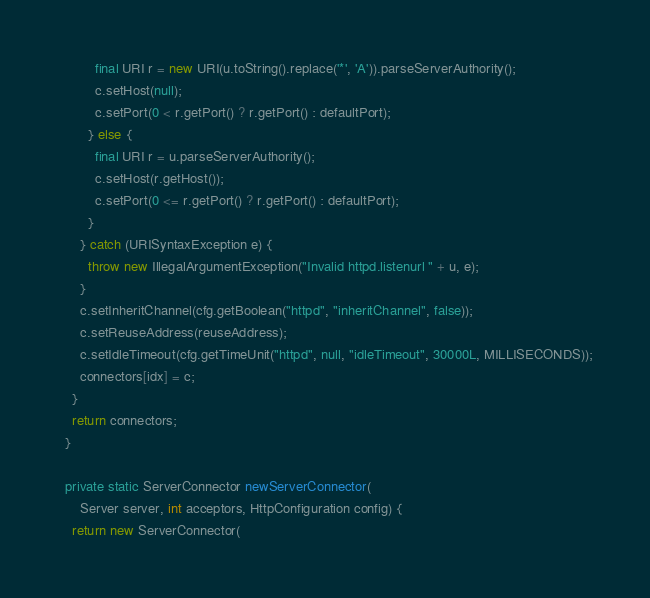Convert code to text. <code><loc_0><loc_0><loc_500><loc_500><_Java_>          final URI r = new URI(u.toString().replace('*', 'A')).parseServerAuthority();
          c.setHost(null);
          c.setPort(0 < r.getPort() ? r.getPort() : defaultPort);
        } else {
          final URI r = u.parseServerAuthority();
          c.setHost(r.getHost());
          c.setPort(0 <= r.getPort() ? r.getPort() : defaultPort);
        }
      } catch (URISyntaxException e) {
        throw new IllegalArgumentException("Invalid httpd.listenurl " + u, e);
      }
      c.setInheritChannel(cfg.getBoolean("httpd", "inheritChannel", false));
      c.setReuseAddress(reuseAddress);
      c.setIdleTimeout(cfg.getTimeUnit("httpd", null, "idleTimeout", 30000L, MILLISECONDS));
      connectors[idx] = c;
    }
    return connectors;
  }

  private static ServerConnector newServerConnector(
      Server server, int acceptors, HttpConfiguration config) {
    return new ServerConnector(</code> 